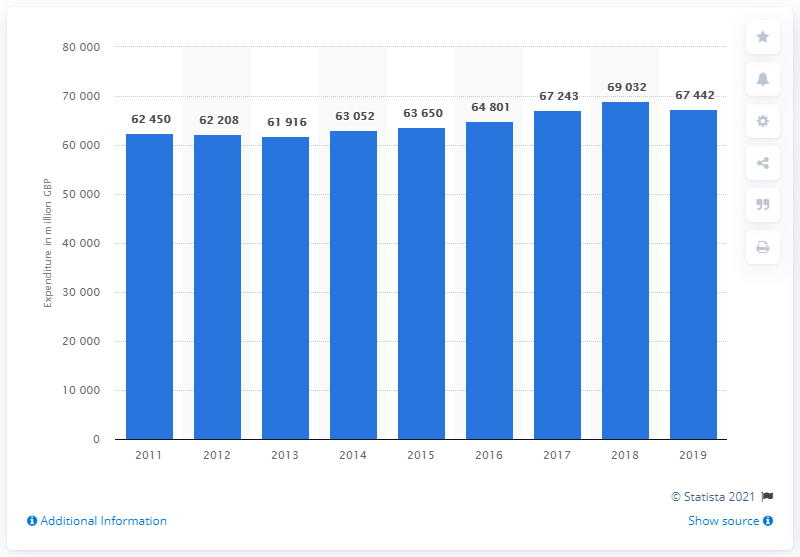Specify some key components in this picture. In 2018, households in the UK spent approximately 69,032 on personal transport equipment. 